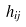<formula> <loc_0><loc_0><loc_500><loc_500>h _ { i j }</formula> 